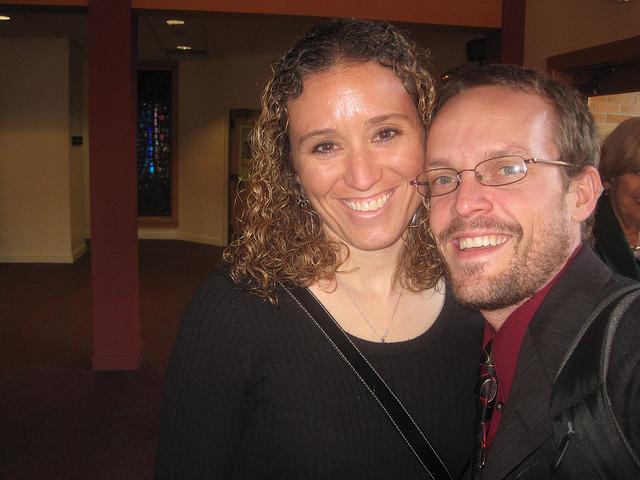Is the ladies necklace onyx?
Be succinct. No. Who is wearing glasses?
Answer briefly. Man. What is the man holding up to his chest?
Short answer required. Nothing. What are they wearing that matches?
Give a very brief answer. Tops. Is this at church?
Keep it brief. Yes. What is behind and to the left of the woman?
Answer briefly. Window. Is this man wearing glasses?
Short answer required. Yes. 